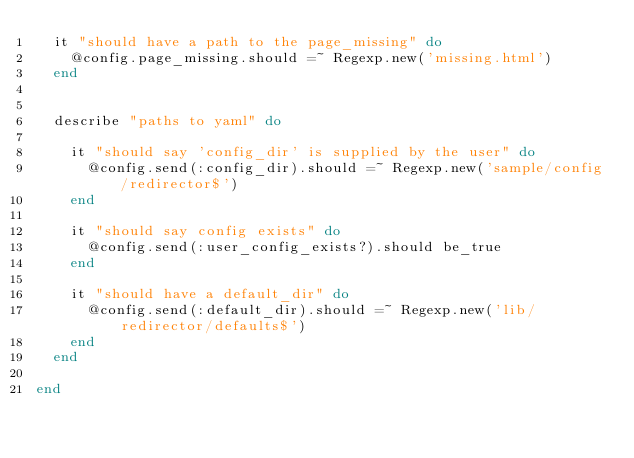Convert code to text. <code><loc_0><loc_0><loc_500><loc_500><_Ruby_>  it "should have a path to the page_missing" do
    @config.page_missing.should =~ Regexp.new('missing.html')
  end
  

  describe "paths to yaml" do
    
    it "should say 'config_dir' is supplied by the user" do
      @config.send(:config_dir).should =~ Regexp.new('sample/config/redirector$')
    end
  
    it "should say config exists" do
      @config.send(:user_config_exists?).should be_true
    end
  
    it "should have a default_dir" do
      @config.send(:default_dir).should =~ Regexp.new('lib/redirector/defaults$')
    end
  end
  
end</code> 